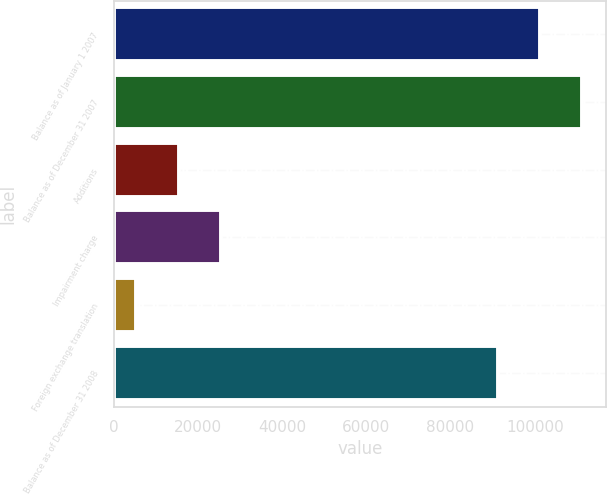<chart> <loc_0><loc_0><loc_500><loc_500><bar_chart><fcel>Balance as of January 1 2007<fcel>Balance as of December 31 2007<fcel>Additions<fcel>Impairment charge<fcel>Foreign exchange translation<fcel>Balance as of December 31 2008<nl><fcel>101294<fcel>111302<fcel>15412.1<fcel>25420.2<fcel>5404<fcel>91286<nl></chart> 